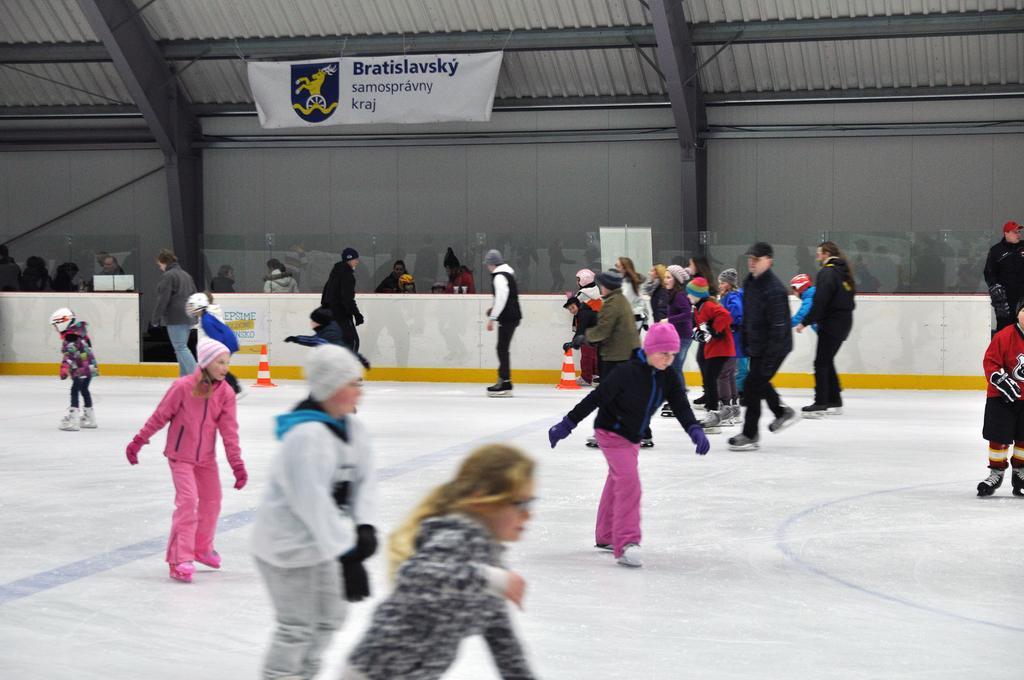Describe this image in one or two sentences. There are many people doing ice skating. Some are wearing caps and gloves. In the back there is a wall. On that there is a banner. Also there are traffic cones. 